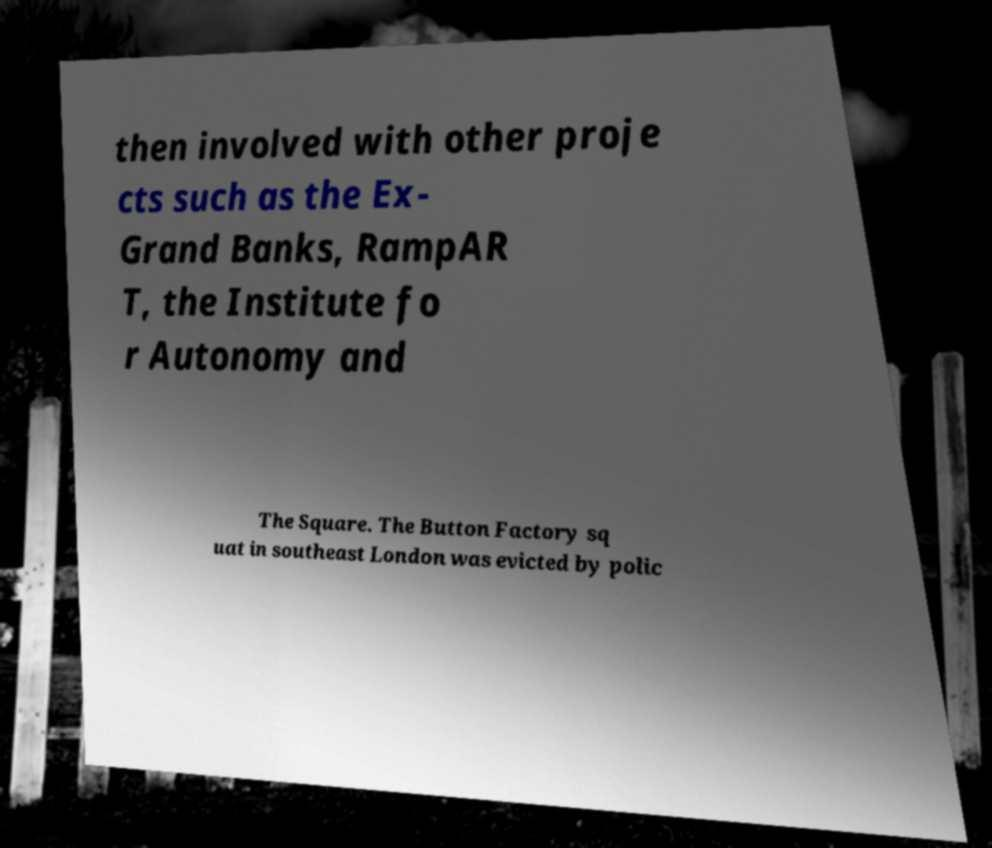I need the written content from this picture converted into text. Can you do that? then involved with other proje cts such as the Ex- Grand Banks, RampAR T, the Institute fo r Autonomy and The Square. The Button Factory sq uat in southeast London was evicted by polic 